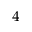<formula> <loc_0><loc_0><loc_500><loc_500>^ { 4 }</formula> 